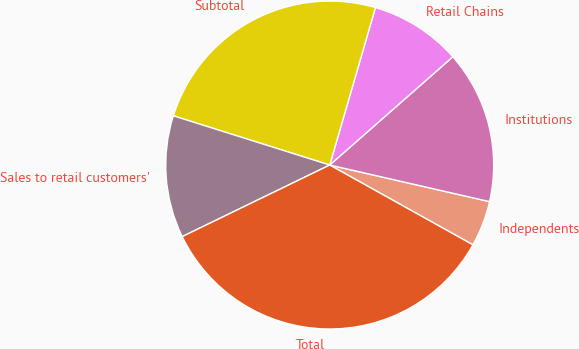Convert chart. <chart><loc_0><loc_0><loc_500><loc_500><pie_chart><fcel>Independents<fcel>Institutions<fcel>Retail Chains<fcel>Subtotal<fcel>Sales to retail customers'<fcel>Total<nl><fcel>4.51%<fcel>15.06%<fcel>9.02%<fcel>24.64%<fcel>12.04%<fcel>34.71%<nl></chart> 